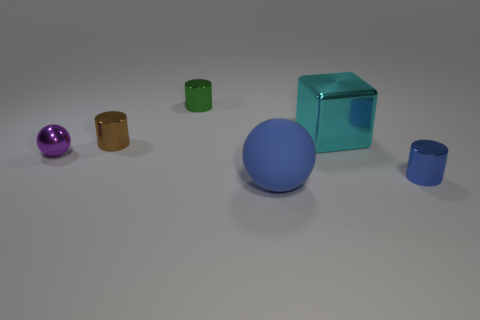What color is the tiny cylinder that is both to the right of the brown shiny cylinder and behind the blue cylinder?
Provide a short and direct response. Green. Are there any shiny things that have the same color as the cube?
Provide a short and direct response. No. Are the big blue ball and the purple thing made of the same material?
Your answer should be very brief. No. There is a big blue ball; what number of tiny brown metal objects are right of it?
Give a very brief answer. 0. What is the material of the object that is in front of the small sphere and behind the blue ball?
Offer a very short reply. Metal. What number of brown metallic cylinders are the same size as the cyan object?
Offer a terse response. 0. The big thing in front of the tiny shiny object right of the blue sphere is what color?
Ensure brevity in your answer.  Blue. Is there a small brown sphere?
Your answer should be compact. No. Is the cyan metal object the same shape as the tiny brown metal thing?
Provide a succinct answer. No. The metallic cylinder that is the same color as the large rubber thing is what size?
Your response must be concise. Small. 